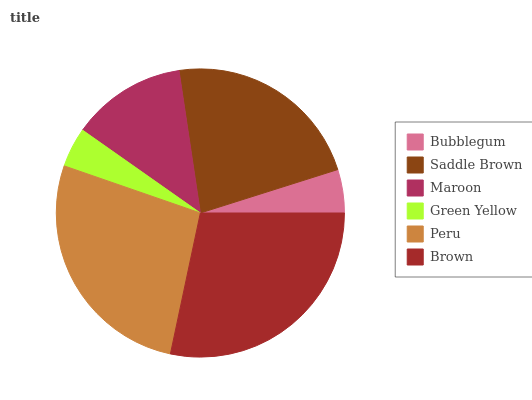Is Green Yellow the minimum?
Answer yes or no. Yes. Is Brown the maximum?
Answer yes or no. Yes. Is Saddle Brown the minimum?
Answer yes or no. No. Is Saddle Brown the maximum?
Answer yes or no. No. Is Saddle Brown greater than Bubblegum?
Answer yes or no. Yes. Is Bubblegum less than Saddle Brown?
Answer yes or no. Yes. Is Bubblegum greater than Saddle Brown?
Answer yes or no. No. Is Saddle Brown less than Bubblegum?
Answer yes or no. No. Is Saddle Brown the high median?
Answer yes or no. Yes. Is Maroon the low median?
Answer yes or no. Yes. Is Green Yellow the high median?
Answer yes or no. No. Is Peru the low median?
Answer yes or no. No. 